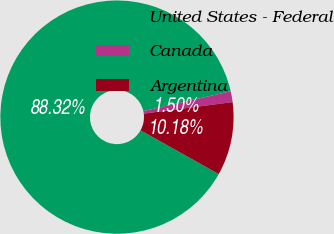Convert chart to OTSL. <chart><loc_0><loc_0><loc_500><loc_500><pie_chart><fcel>United States - Federal<fcel>Canada<fcel>Argentina<nl><fcel>88.32%<fcel>1.5%<fcel>10.18%<nl></chart> 